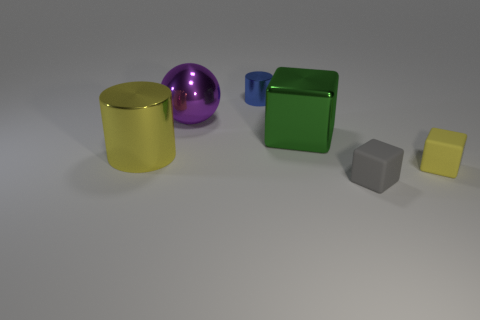Add 2 green metal objects. How many objects exist? 8 Subtract all spheres. How many objects are left? 5 Add 4 cylinders. How many cylinders are left? 6 Add 6 tiny blue objects. How many tiny blue objects exist? 7 Subtract 0 cyan balls. How many objects are left? 6 Subtract all large yellow things. Subtract all gray objects. How many objects are left? 4 